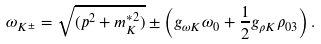Convert formula to latex. <formula><loc_0><loc_0><loc_500><loc_500>\omega _ { K ^ { \pm } } = \sqrt { ( p ^ { 2 } + m _ { K } ^ { * 2 } ) } \pm \left ( g _ { \omega K } \omega _ { 0 } + \frac { 1 } { 2 } g _ { \rho K } \rho _ { 0 3 } \right ) .</formula> 